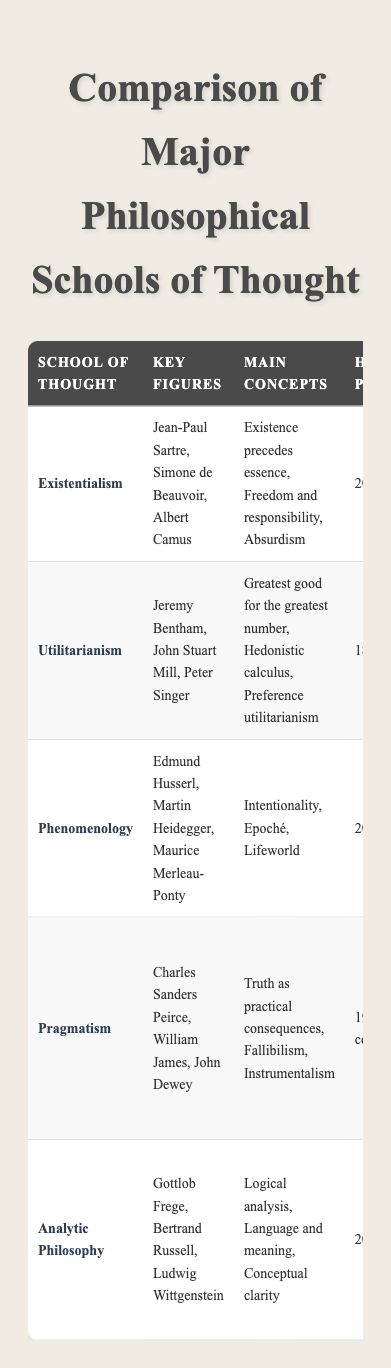What are the key figures in Existentialism? Based on the table, the key figures listed under Existentialism are Jean-Paul Sartre, Simone de Beauvoir, and Albert Camus.
Answer: Jean-Paul Sartre, Simone de Beauvoir, Albert Camus Which school of thought emphasizes "Truth as practical consequences"? According to the table, Pragmatism is the school of thought that emphasizes "Truth as practical consequences."
Answer: Pragmatism How many philosophical schools of thought have "High" contemporary relevance? By reviewing the table, Existentialism, Utilitarianism, and Analytic Philosophy are categorized as having "High" contemporary relevance. Therefore, there are three schools.
Answer: 3 Is Phenomenology considered to have high contemporary relevance? From the table, Phenomenology is noted to have "Moderate" contemporary relevance, thus it does not have "High" contemporary relevance.
Answer: No Which influential work is associated with Utilitarianism? The table lists "Utilitarianism" and "Animal Liberation" as influential works associated with Utilitarianism.
Answer: Utilitarianism, Animal Liberation What is the main ethical implication of Analytic Philosophy? From the data in the table, Analytic Philosophy's main ethical implication is the "Emphasis on precision and clarity in moral reasoning."
Answer: Emphasis on precision and clarity in moral reasoning Which school of thought has the earliest historical period and what is it? By examining the historical periods in the table, Utilitarianism, with a historical period of "18th-21st century," is the earliest school listed.
Answer: Utilitarianism, 18th-21st century If we consider the concepts related to three schools of thought, what would be the sum of schools that emphasize subjective experience and practical outcomes? The terms related to Phenomenology emphasize "subjective experience," while Pragmatism focuses on "practical outcomes." Therefore, if we count them as two schools emphasizing these aspects, the sum is 2.
Answer: 2 